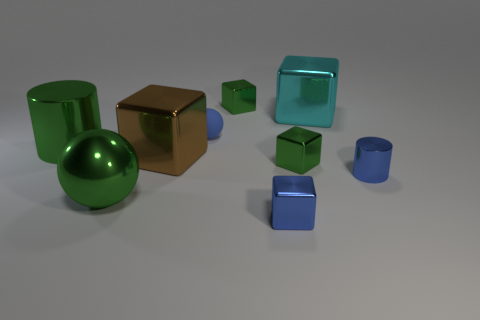Subtract all brown cubes. How many cubes are left? 4 Subtract all large cyan cubes. How many cubes are left? 4 Subtract all yellow blocks. Subtract all purple cylinders. How many blocks are left? 5 Add 1 purple balls. How many objects exist? 10 Subtract all cylinders. How many objects are left? 7 Add 6 tiny red balls. How many tiny red balls exist? 6 Subtract 1 green cubes. How many objects are left? 8 Subtract all small blue metal cylinders. Subtract all brown blocks. How many objects are left? 7 Add 4 small blue shiny cylinders. How many small blue shiny cylinders are left? 5 